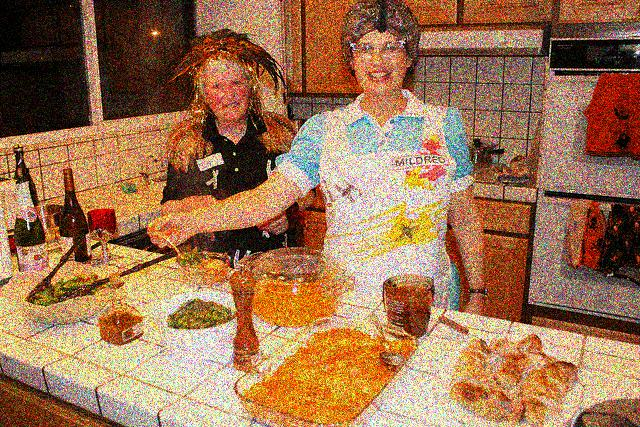Are there any distinctive objects on the counter that suggest what they might be cooking? The counter features several distinct items such as a bowl of what appears to be dough, a plate with greens which could be herbs or vegetables, a glass of a yellow-orange liquid that might be a beverage or a cooking ingredient, and a loaf of bread. These items suggest the women could be making a meal that involves baking and possibly includes a salad or herbed dish. 